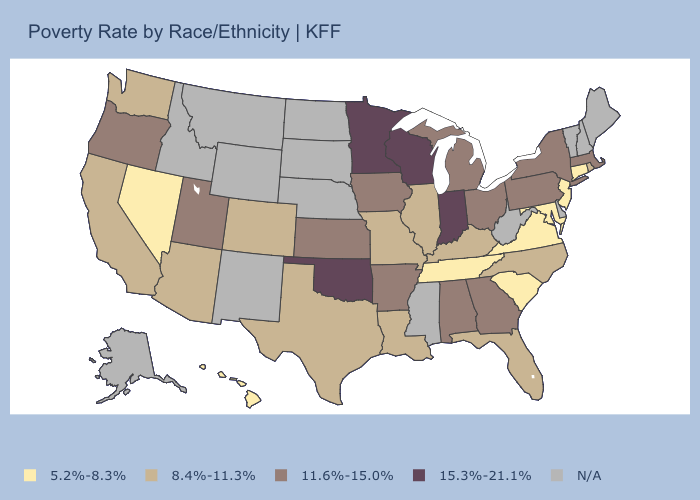What is the highest value in states that border Utah?
Short answer required. 8.4%-11.3%. Name the states that have a value in the range N/A?
Answer briefly. Alaska, Delaware, Idaho, Maine, Mississippi, Montana, Nebraska, New Hampshire, New Mexico, North Dakota, South Dakota, Vermont, West Virginia, Wyoming. Does the map have missing data?
Answer briefly. Yes. Name the states that have a value in the range N/A?
Keep it brief. Alaska, Delaware, Idaho, Maine, Mississippi, Montana, Nebraska, New Hampshire, New Mexico, North Dakota, South Dakota, Vermont, West Virginia, Wyoming. Among the states that border Connecticut , which have the lowest value?
Short answer required. Rhode Island. What is the value of New Mexico?
Concise answer only. N/A. Is the legend a continuous bar?
Give a very brief answer. No. Does Oklahoma have the highest value in the South?
Answer briefly. Yes. What is the value of Massachusetts?
Quick response, please. 11.6%-15.0%. Name the states that have a value in the range 5.2%-8.3%?
Answer briefly. Connecticut, Hawaii, Maryland, Nevada, New Jersey, South Carolina, Tennessee, Virginia. Name the states that have a value in the range 11.6%-15.0%?
Short answer required. Alabama, Arkansas, Georgia, Iowa, Kansas, Massachusetts, Michigan, New York, Ohio, Oregon, Pennsylvania, Utah. Does Indiana have the highest value in the USA?
Answer briefly. Yes. What is the value of Kentucky?
Give a very brief answer. 8.4%-11.3%. Does Georgia have the highest value in the USA?
Answer briefly. No. 